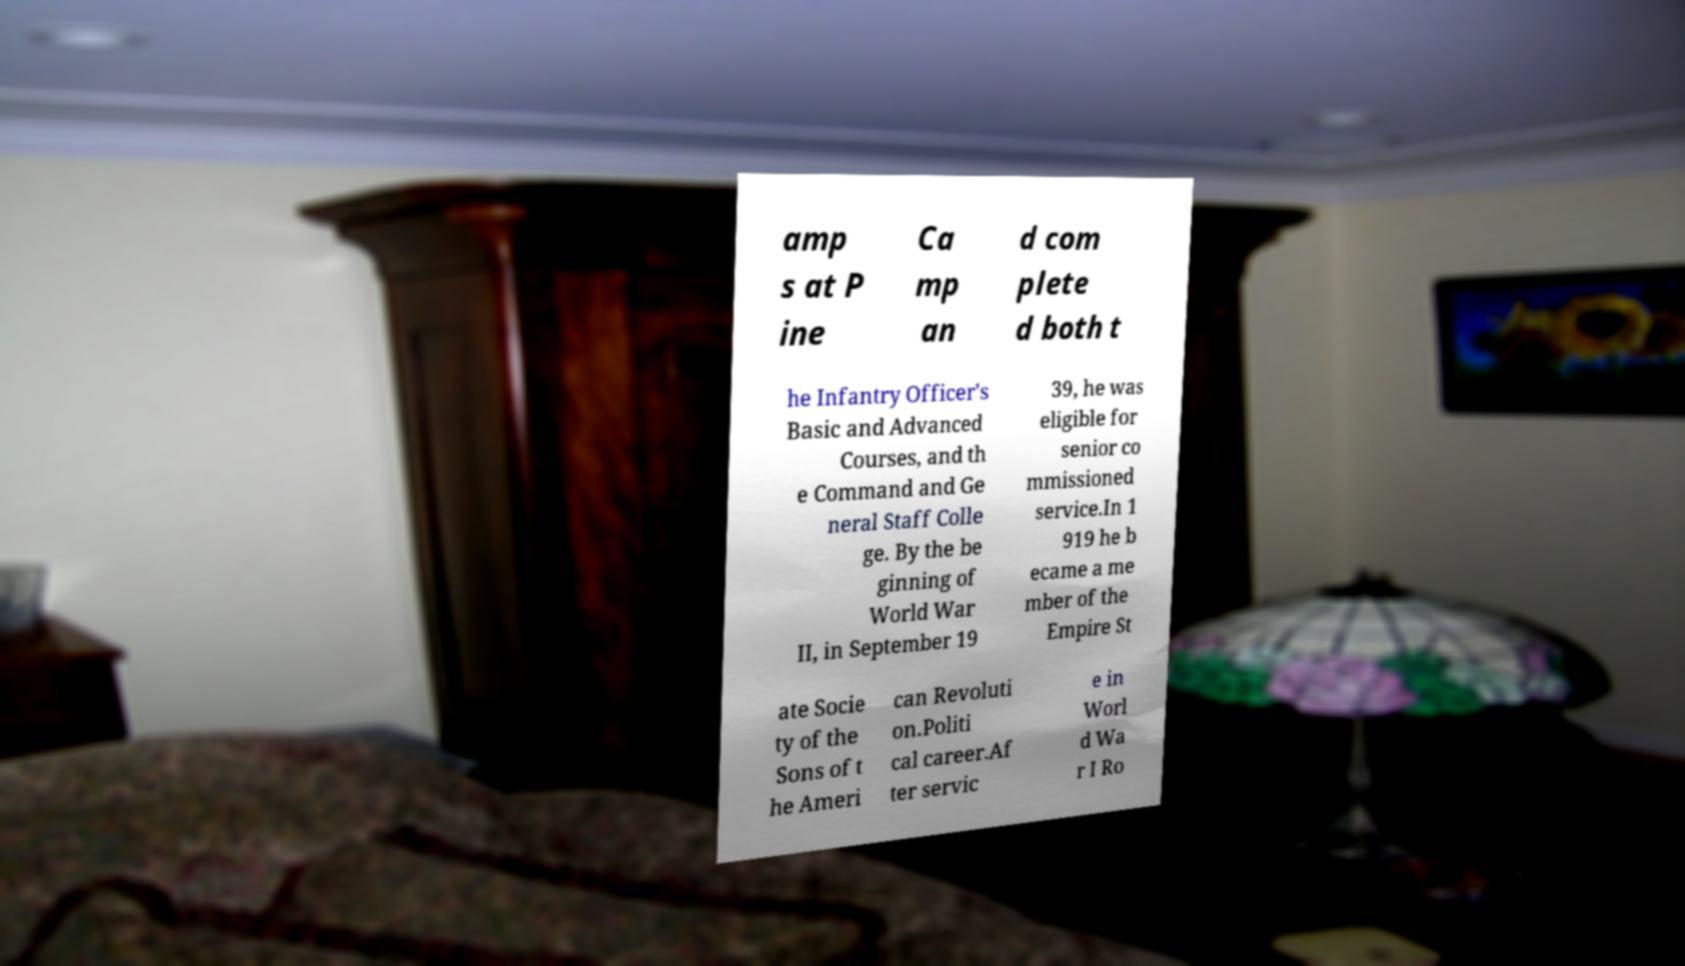Can you accurately transcribe the text from the provided image for me? amp s at P ine Ca mp an d com plete d both t he Infantry Officer's Basic and Advanced Courses, and th e Command and Ge neral Staff Colle ge. By the be ginning of World War II, in September 19 39, he was eligible for senior co mmissioned service.In 1 919 he b ecame a me mber of the Empire St ate Socie ty of the Sons of t he Ameri can Revoluti on.Politi cal career.Af ter servic e in Worl d Wa r I Ro 